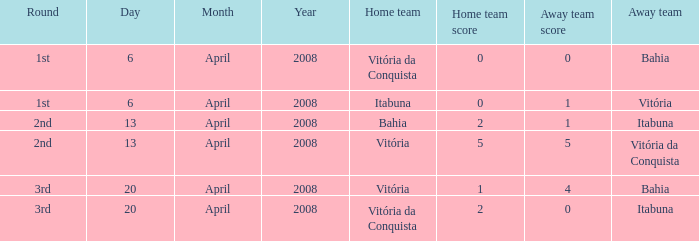Who was the home team on April 13, 2008 when Itabuna was the away team? Bahia. 